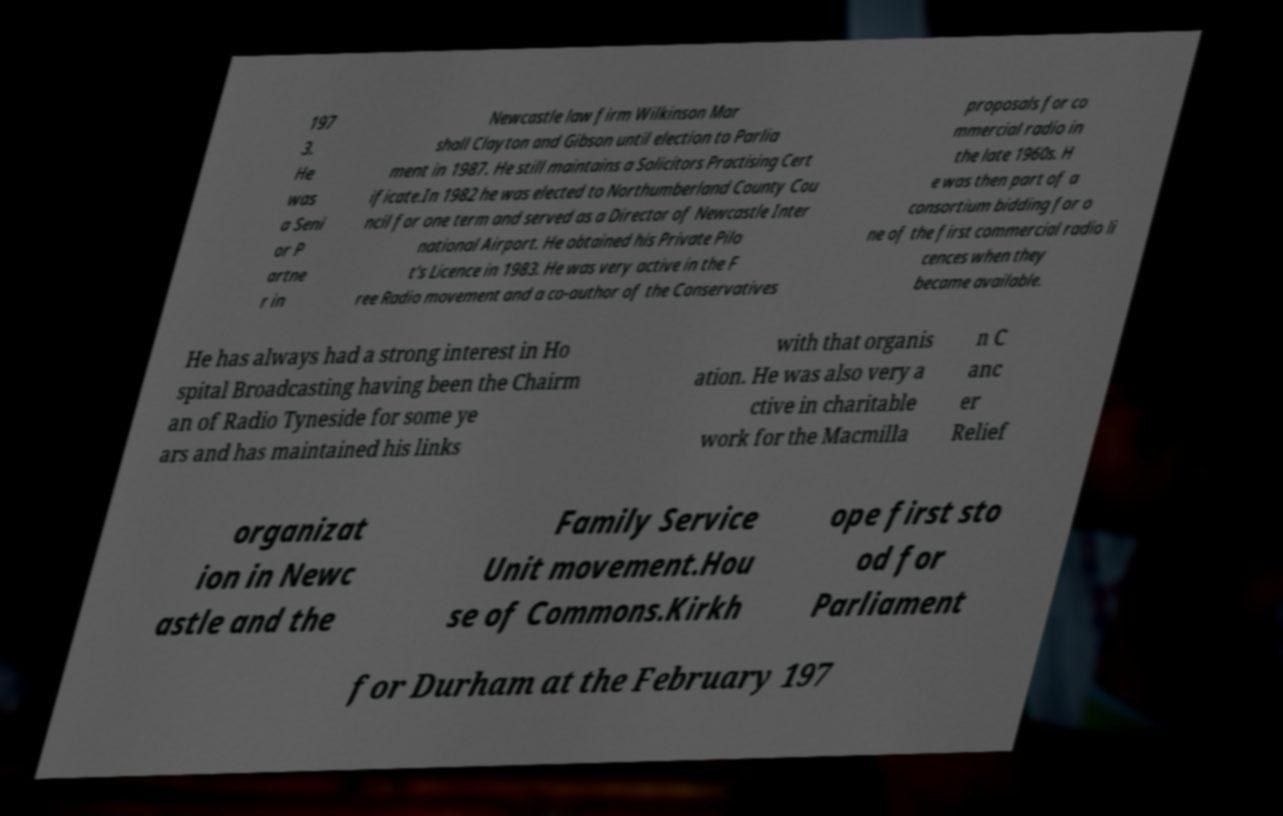Can you accurately transcribe the text from the provided image for me? 197 3. He was a Seni or P artne r in Newcastle law firm Wilkinson Mar shall Clayton and Gibson until election to Parlia ment in 1987. He still maintains a Solicitors Practising Cert ificate.In 1982 he was elected to Northumberland County Cou ncil for one term and served as a Director of Newcastle Inter national Airport. He obtained his Private Pilo t's Licence in 1983. He was very active in the F ree Radio movement and a co-author of the Conservatives proposals for co mmercial radio in the late 1960s. H e was then part of a consortium bidding for o ne of the first commercial radio li cences when they became available. He has always had a strong interest in Ho spital Broadcasting having been the Chairm an of Radio Tyneside for some ye ars and has maintained his links with that organis ation. He was also very a ctive in charitable work for the Macmilla n C anc er Relief organizat ion in Newc astle and the Family Service Unit movement.Hou se of Commons.Kirkh ope first sto od for Parliament for Durham at the February 197 